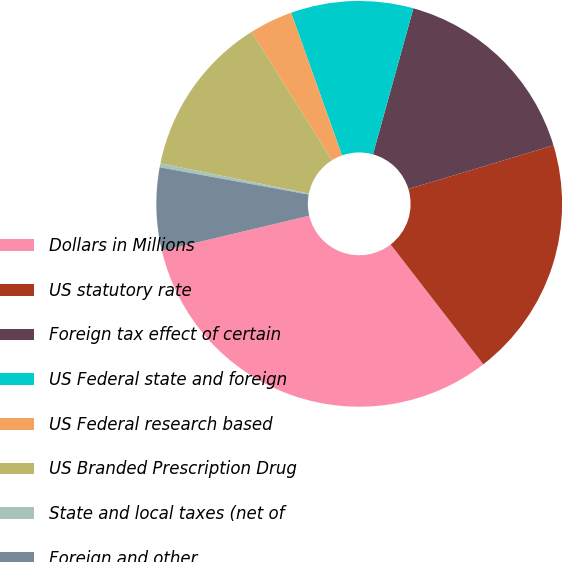Convert chart. <chart><loc_0><loc_0><loc_500><loc_500><pie_chart><fcel>Dollars in Millions<fcel>US statutory rate<fcel>Foreign tax effect of certain<fcel>US Federal state and foreign<fcel>US Federal research based<fcel>US Branded Prescription Drug<fcel>State and local taxes (net of<fcel>Foreign and other<nl><fcel>31.76%<fcel>19.18%<fcel>16.04%<fcel>9.75%<fcel>3.46%<fcel>12.89%<fcel>0.32%<fcel>6.6%<nl></chart> 